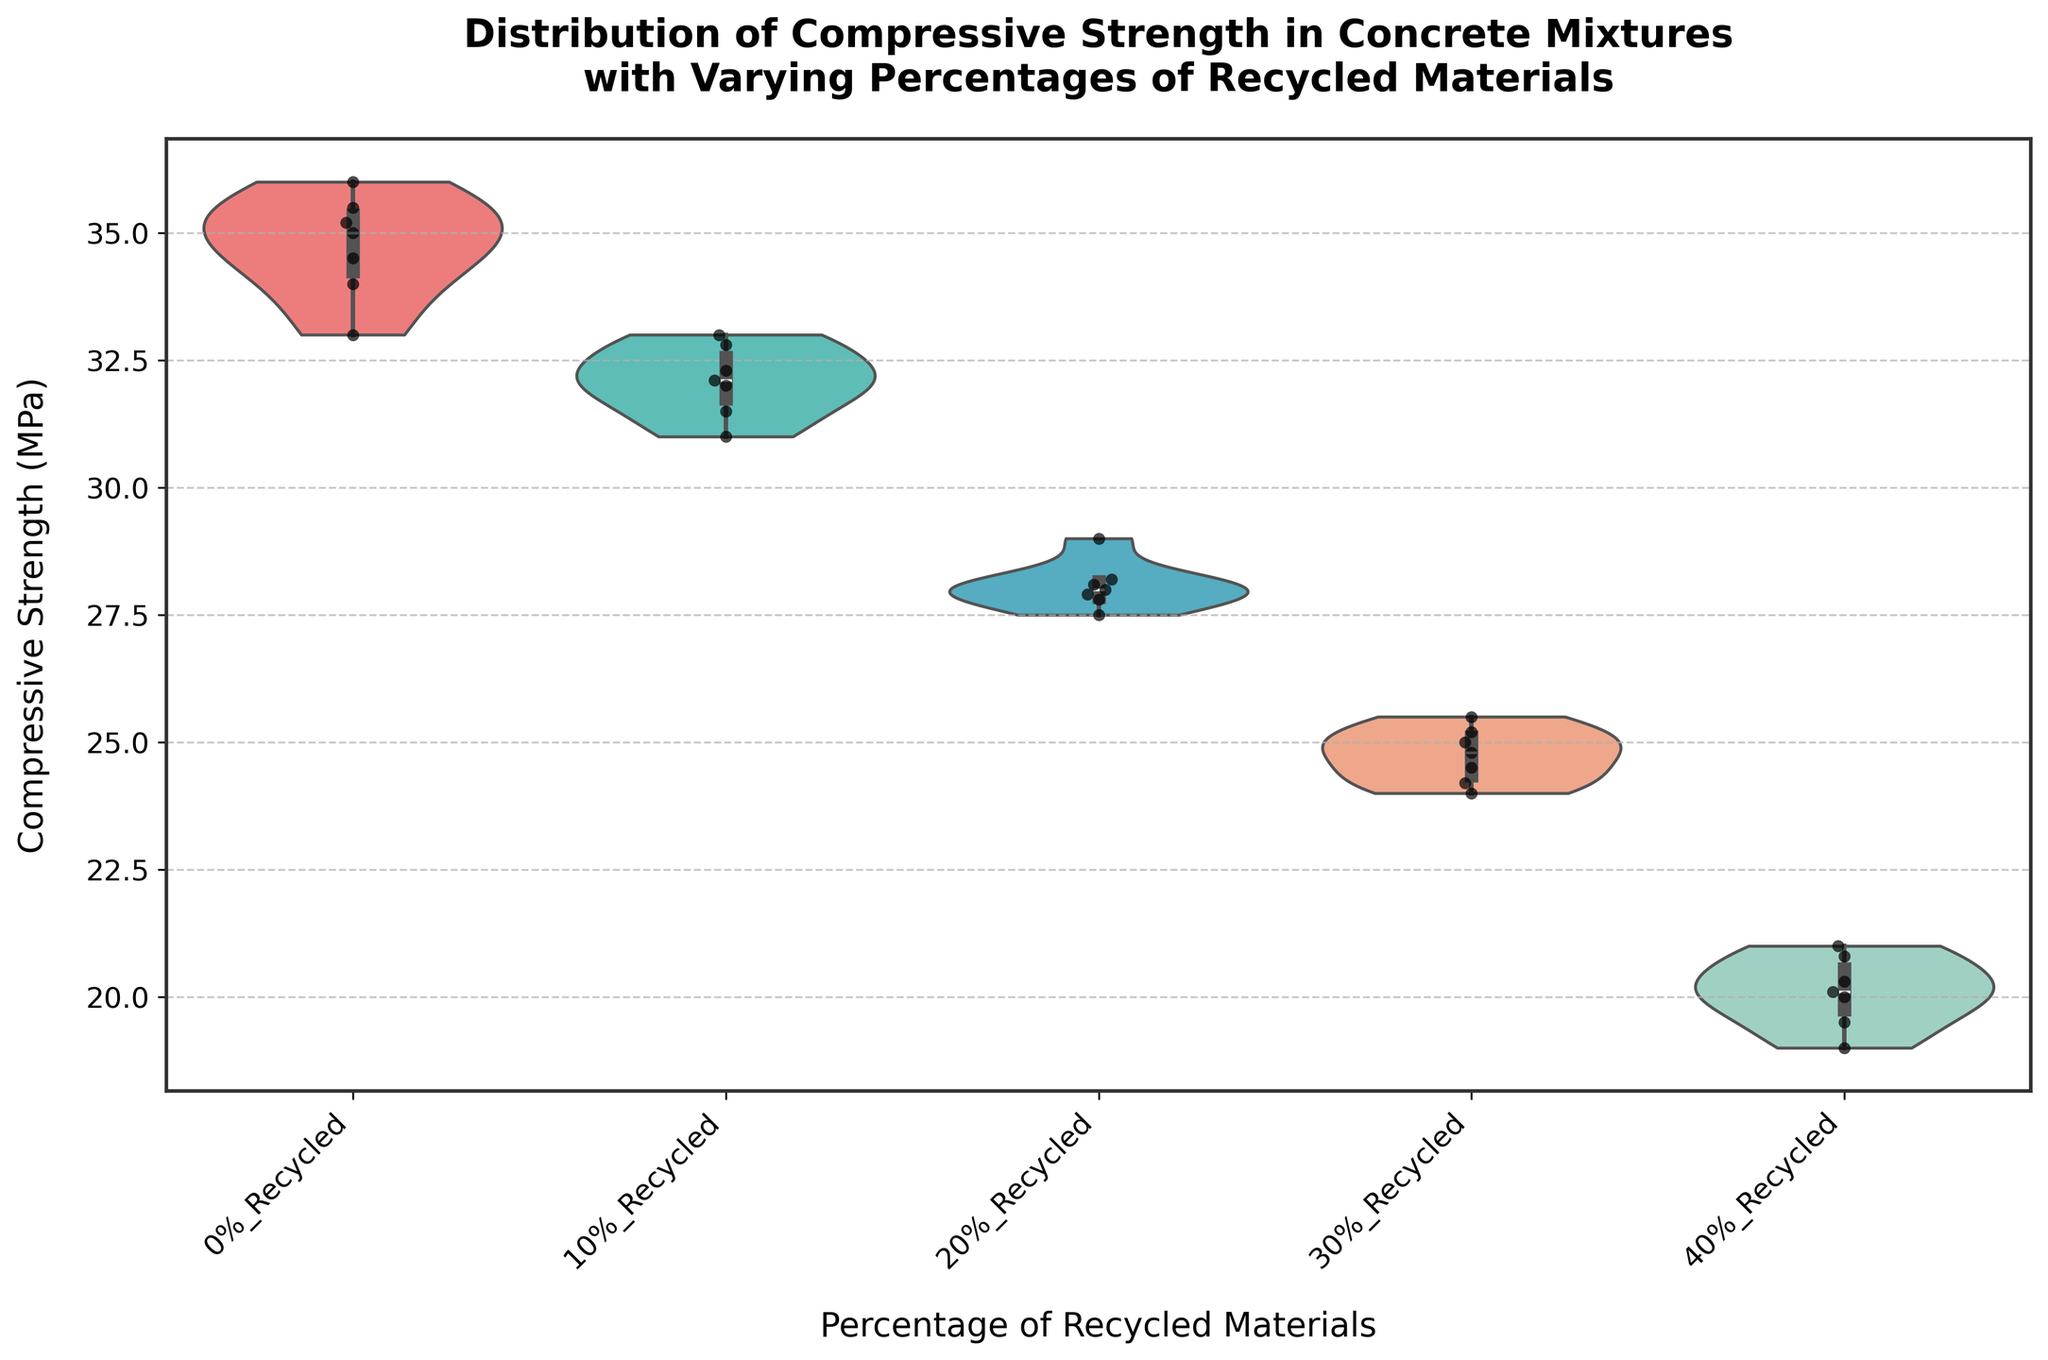What's the title of the figure? The title is located at the top of the figure. It reads "Distribution of Compressive Strength in Concrete Mixtures with Varying Percentages of Recycled Materials".
Answer: Distribution of Compressive Strength in Concrete Mixtures with Varying Percentages of Recycled Materials Which mix type has the highest median compressive strength? The median is visible as the center line in the violin plots. The mix type 0% Recycled has the highest median compressive strength as its median line is positioned higher than the others.
Answer: 0% Recycled What are the compressive strength ranges for the 30% Recycled mix type? The range can be observed from the uppermost and lowermost points of the violin plot for the 30% Recycled mix type. It ranges approximately from 24 to 25.5 MPa.
Answer: 24 to 25.5 MPa Which mix type shows the largest spread in compressive strength values? The largest spread is indicated by the violin plot that appears widest vertically. The 40% Recycled mix type has the largest spread with values ranging approximately from 19 to 21 MPa.
Answer: 40% Recycled How does the mean compressive strength for the 20% Recycled mix compare to the 10% Recycled mix? The mean is visually indicated by black points plotted within the violins. Observing the means, 10% Recycled appears slightly higher than 20% Recycled.
Answer: 10% Recycled is higher What patterns exist in compressive strength as the percentage of recycled materials increases? Observing the progression of the violin plots from 0% to 40% Recycled, there is a noticeable decrease in both the median and the overall range of compressive strength values.
Answer: Decrease in compressive strength Is the data for the 0% Recycled mix more tightly clustered or more spread out than the 20% Recycled mix? The tightness of clustering is visible by how narrow or wide the violin plots are. The 0% Recycled mix is more tightly clustered as its plot is narrower compared to the wider plot of the 20% Recycled mix.
Answer: More tightly clustered Does the 10% Recycled mix type have any outliers in compressive strength? Outliers, if present, would be represented by individual points outside the main body of the violin plot. The 10% Recycled mix type does not appear to have any clear outliers.
Answer: No Which mix type has the least variance in its compressive strength values? The variance can be inferred by the narrowest plot. The 30% Recycled mix type shows the least variance, as its plot is relatively narrow.
Answer: 30% Recycled By how much does the median compressive strength of the 20% Recycled mix type differ from that of the 40% Recycled mix type? The difference can be found by identifying and subtracting the median positions. The 20% Recycled mix type’s median is about 28 MPa while the 40% Recycled is about 20.5 MPa, thus the difference is 28 - 20.5 = 7.5 MPa.
Answer: 7.5 MPa 